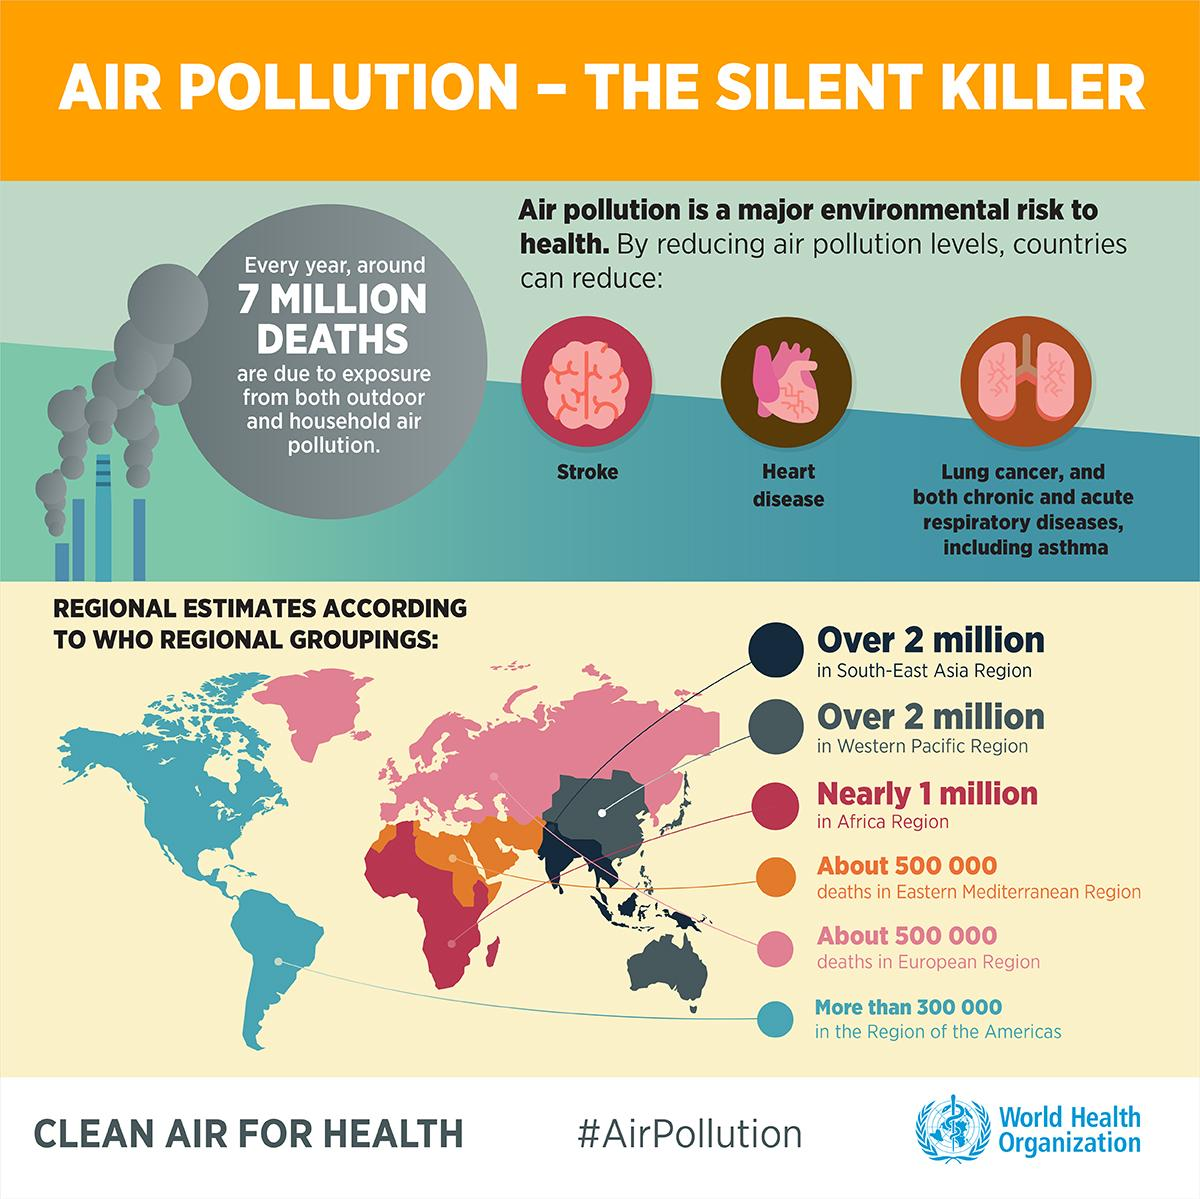List a handful of essential elements in this visual. According to the World Health Organization, an estimated 500,000 deaths are caused by air pollution in the European region annually. The African region is responsible for nearly one million deaths caused by air pollution, according to the World Health Organization. Air pollution has been linked to several health issues, including stroke, which is a disease that can affect the brain. 